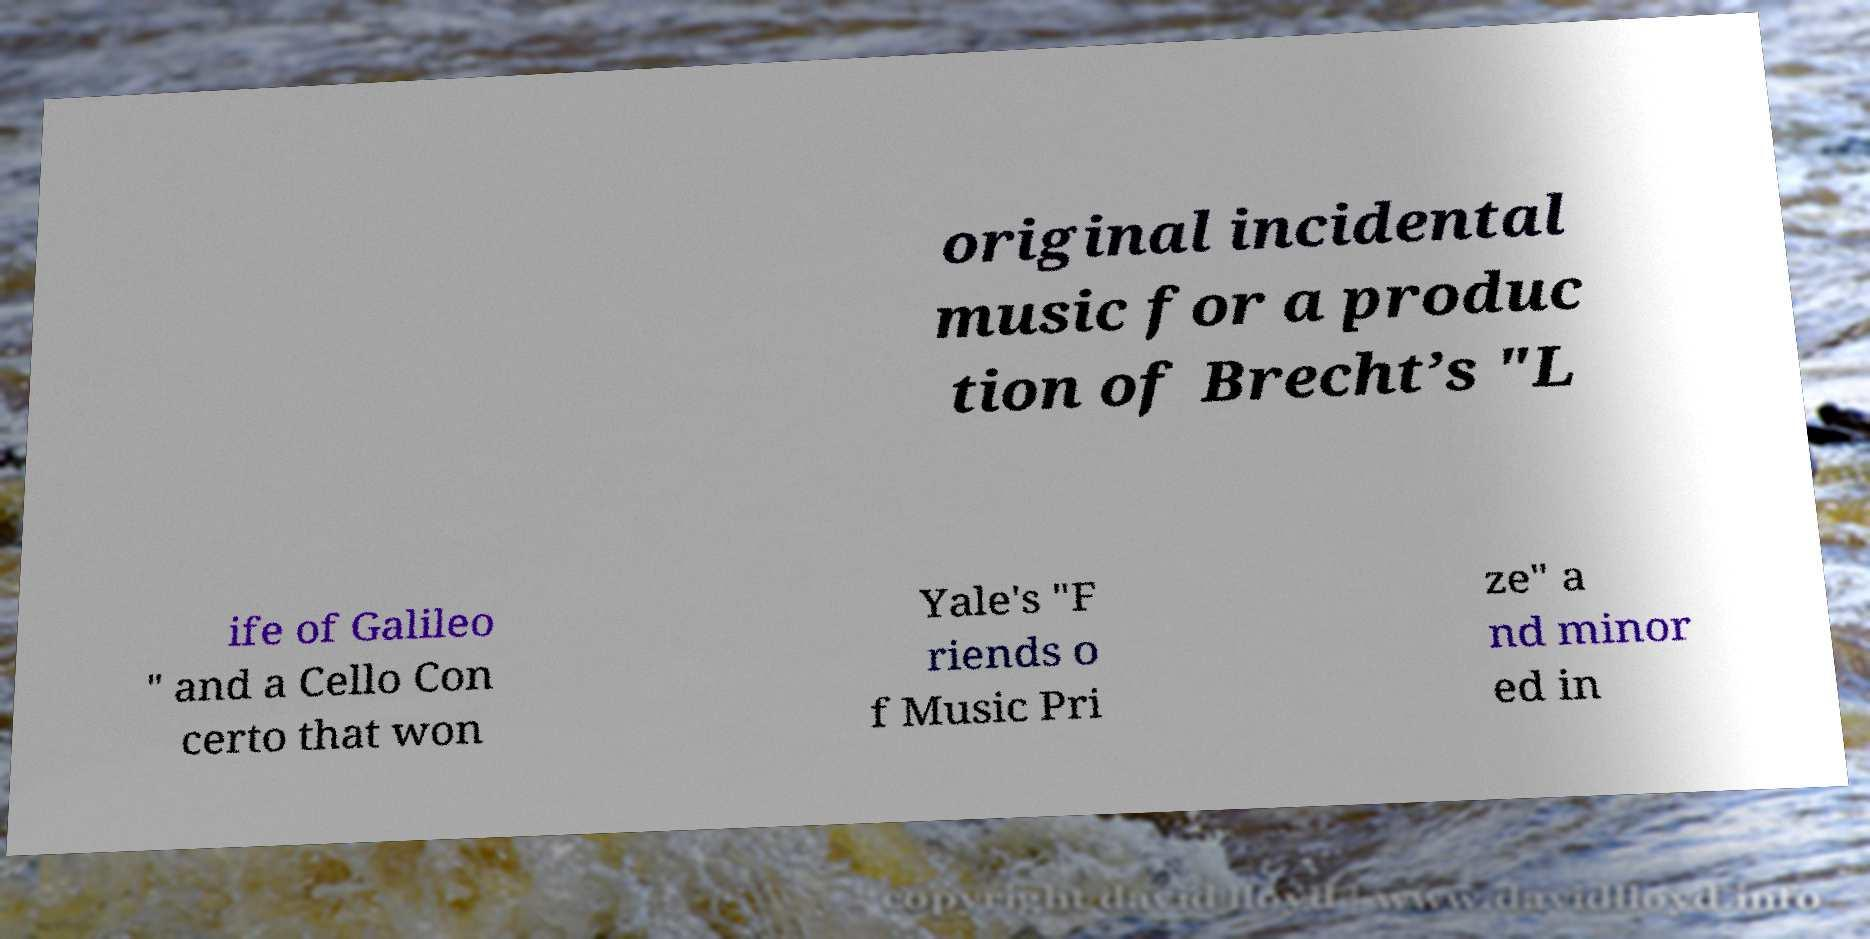Can you read and provide the text displayed in the image?This photo seems to have some interesting text. Can you extract and type it out for me? original incidental music for a produc tion of Brecht’s "L ife of Galileo " and a Cello Con certo that won Yale's "F riends o f Music Pri ze" a nd minor ed in 